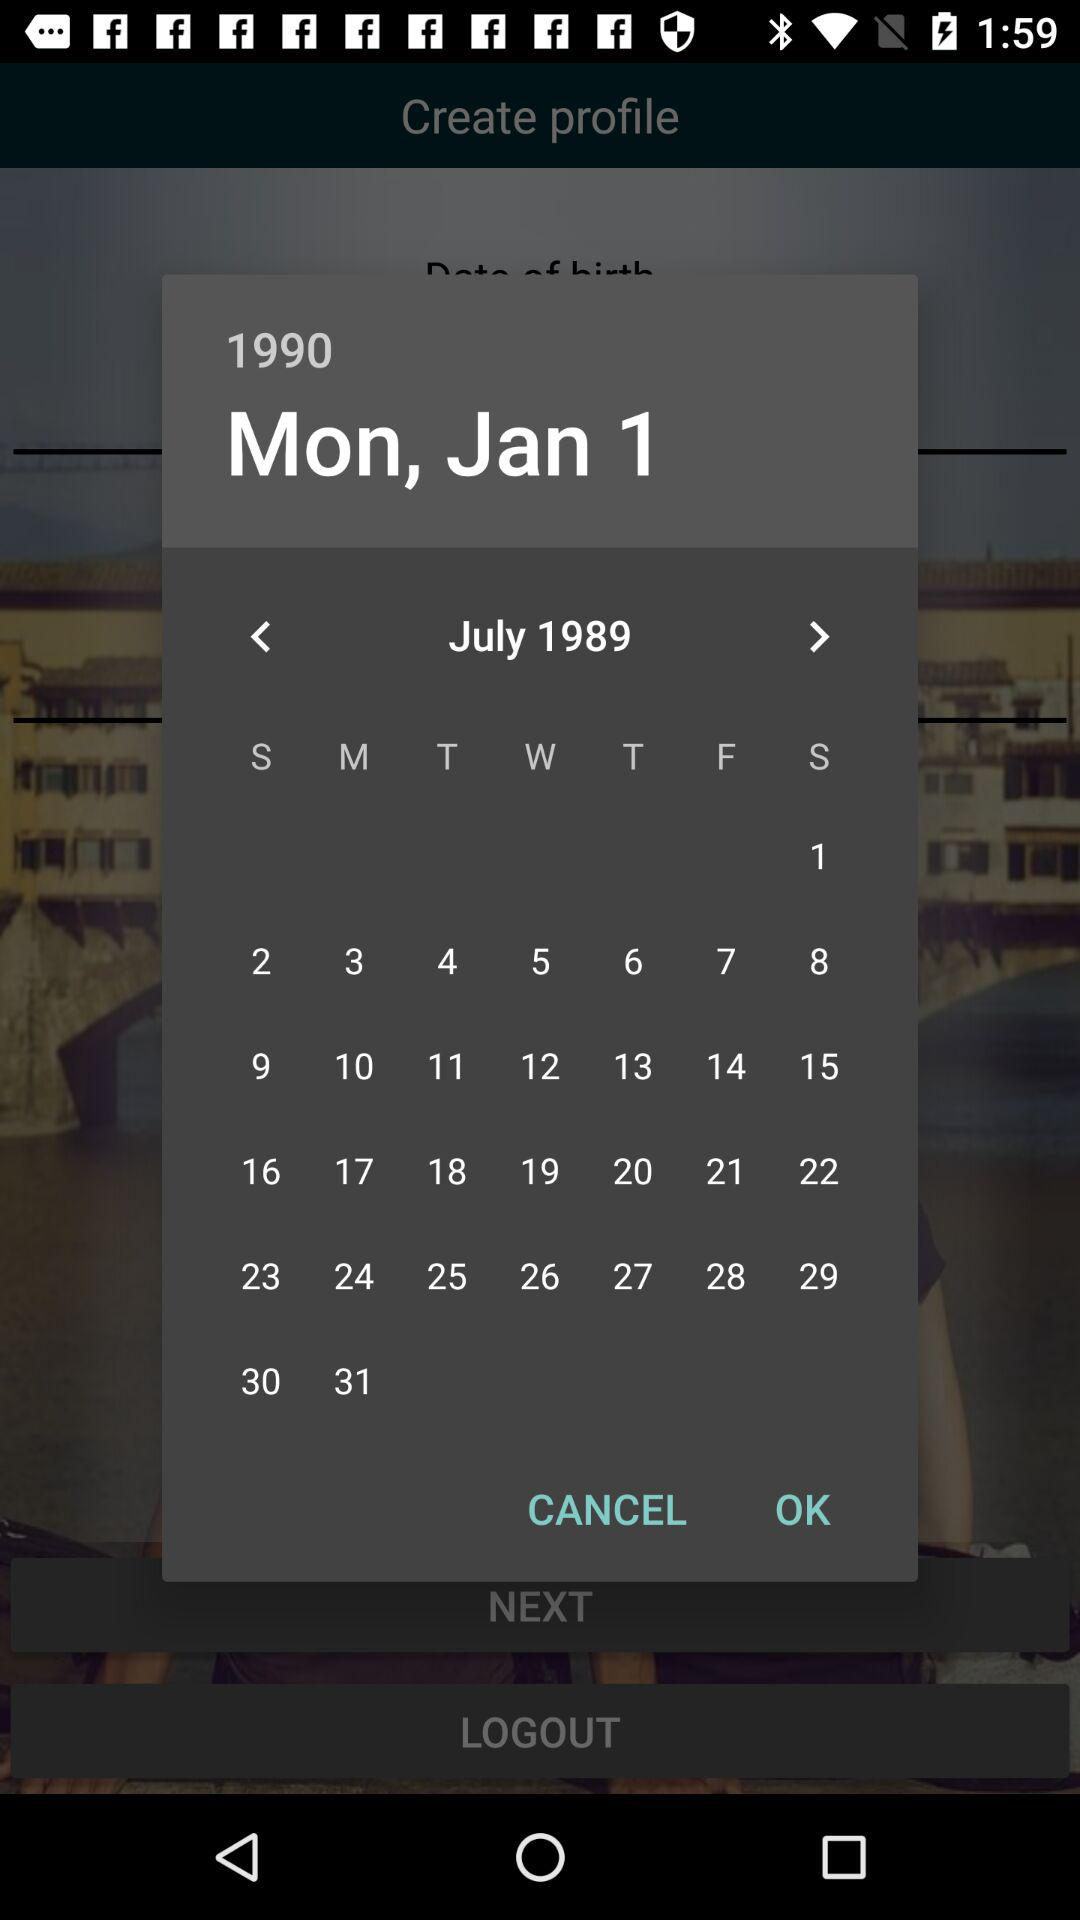Which year is selected on the calendar? The selected year is 1990. 